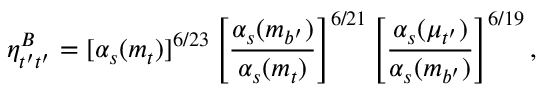Convert formula to latex. <formula><loc_0><loc_0><loc_500><loc_500>\eta _ { t ^ { \prime } t ^ { \prime } } ^ { B } = [ \alpha _ { s } ( m _ { t } ) ] ^ { 6 / 2 3 } \left [ \frac { \alpha _ { s } ( m _ { b ^ { \prime } } ) } { \alpha _ { s } ( m _ { t } ) } \right ] ^ { 6 / 2 1 } \left [ \frac { \alpha _ { s } ( \mu _ { t ^ { \prime } } ) } { \alpha _ { s } ( m _ { b ^ { \prime } } ) } \right ] ^ { 6 / 1 9 } ,</formula> 